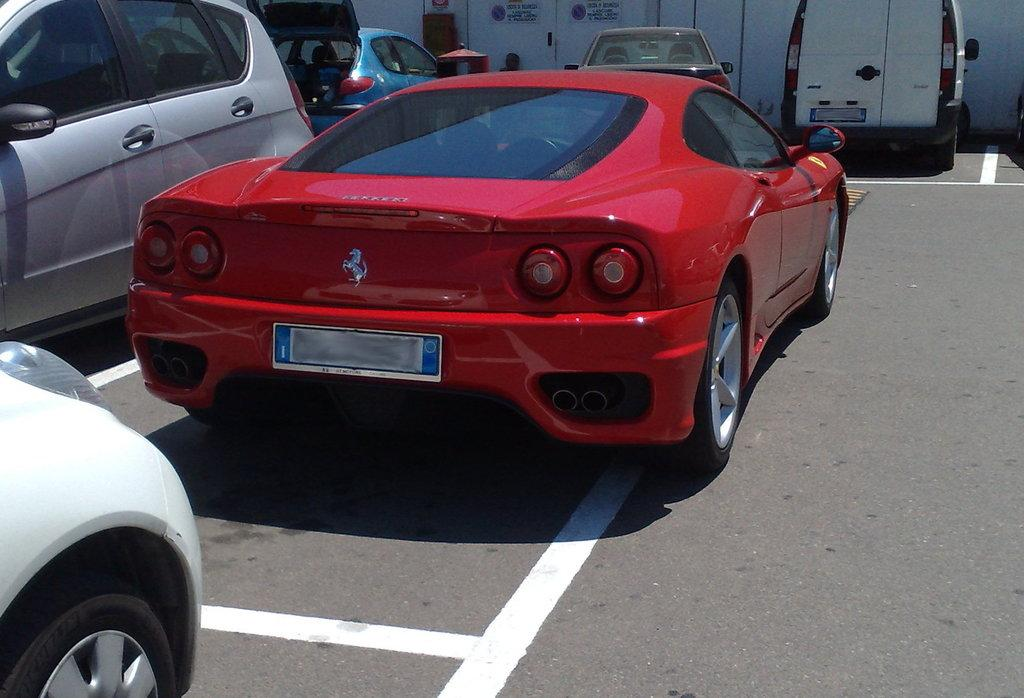What can be seen on the road in the image? There are vehicles on the road in the image. What structure is visible in the image? There is a wall visible in the image. What type of beef is being cooked on the wall in the image? There is no beef or cooking activity present in the image; it only features vehicles on the road and a wall. How many teeth can be seen on the wall in the image? There are no teeth visible on the wall or anywhere else in the image. 